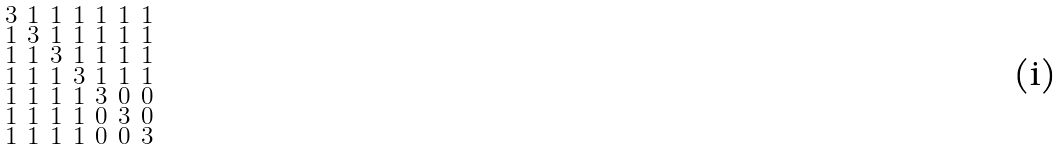<formula> <loc_0><loc_0><loc_500><loc_500>\begin{smallmatrix} 3 & 1 & 1 & 1 & 1 & 1 & 1 \\ 1 & 3 & 1 & 1 & 1 & 1 & 1 \\ 1 & 1 & 3 & 1 & 1 & 1 & 1 \\ 1 & 1 & 1 & 3 & 1 & 1 & 1 \\ 1 & 1 & 1 & 1 & 3 & 0 & 0 \\ 1 & 1 & 1 & 1 & 0 & 3 & 0 \\ 1 & 1 & 1 & 1 & 0 & 0 & 3 \end{smallmatrix}</formula> 